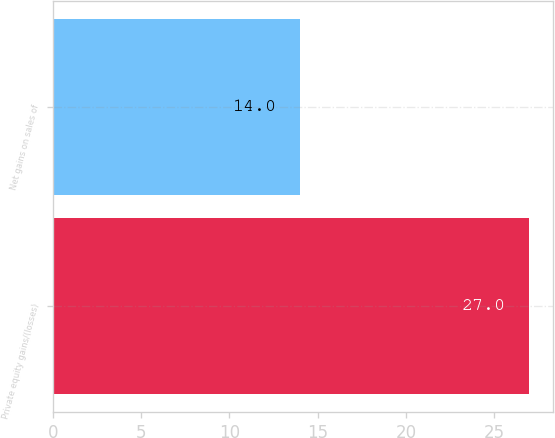Convert chart to OTSL. <chart><loc_0><loc_0><loc_500><loc_500><bar_chart><fcel>Private equity gains/(losses)<fcel>Net gains on sales of<nl><fcel>27<fcel>14<nl></chart> 